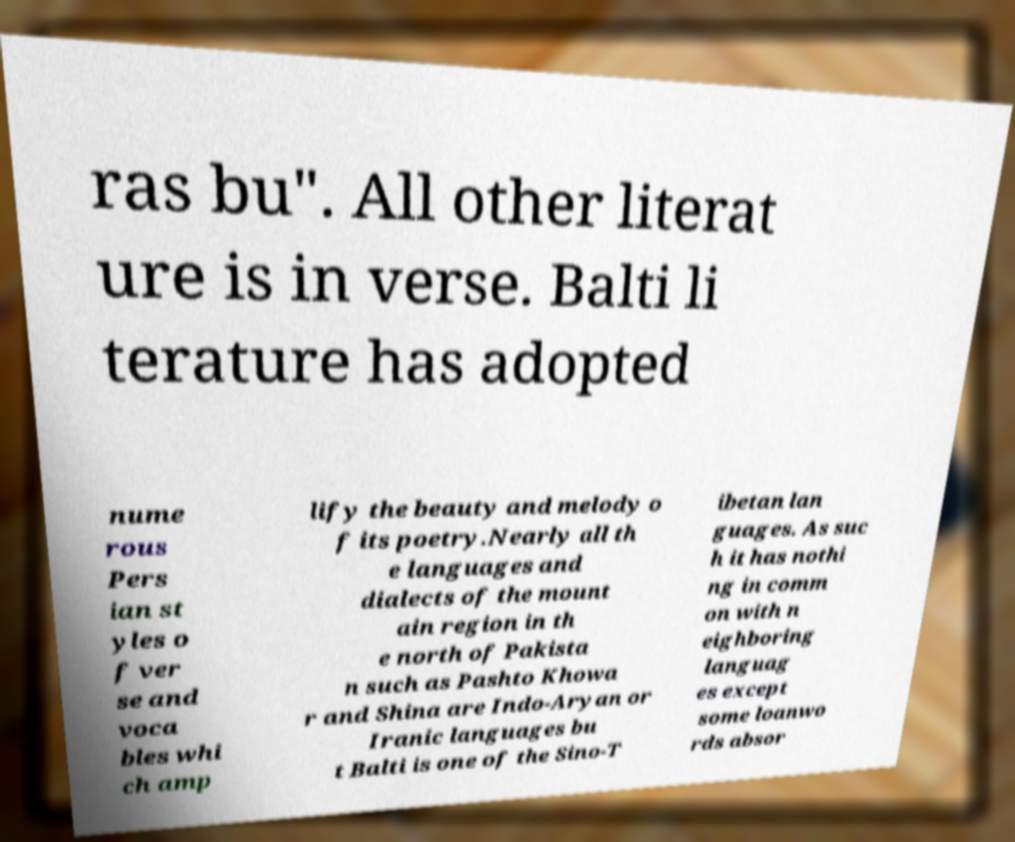Please read and relay the text visible in this image. What does it say? ras bu". All other literat ure is in verse. Balti li terature has adopted nume rous Pers ian st yles o f ver se and voca bles whi ch amp lify the beauty and melody o f its poetry.Nearly all th e languages and dialects of the mount ain region in th e north of Pakista n such as Pashto Khowa r and Shina are Indo-Aryan or Iranic languages bu t Balti is one of the Sino-T ibetan lan guages. As suc h it has nothi ng in comm on with n eighboring languag es except some loanwo rds absor 